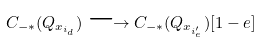<formula> <loc_0><loc_0><loc_500><loc_500>C _ { - * } ( Q _ { x _ { i _ { d } } } ) \longrightarrow C _ { - * } ( Q _ { x _ { i ^ { \prime } _ { e } } } ) [ 1 - e ]</formula> 